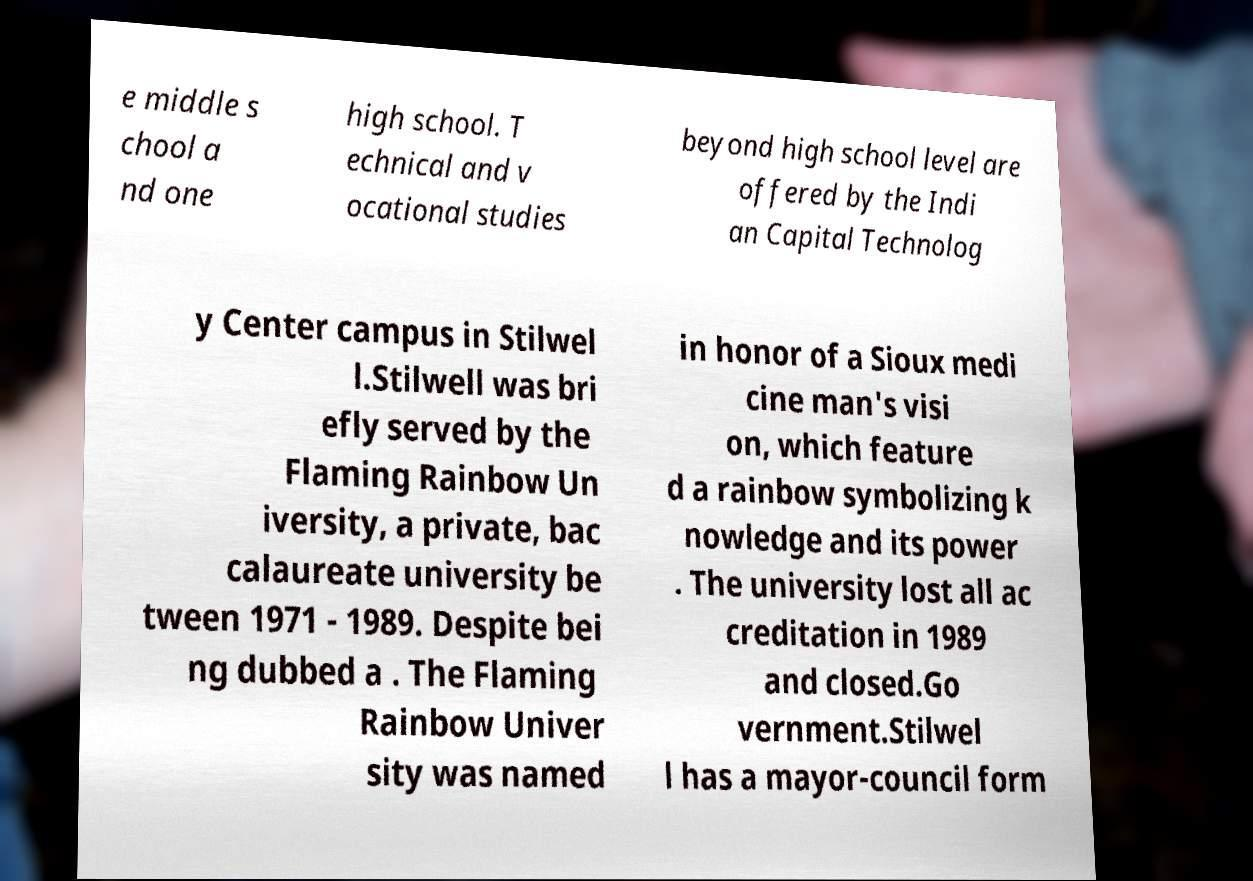Could you assist in decoding the text presented in this image and type it out clearly? e middle s chool a nd one high school. T echnical and v ocational studies beyond high school level are offered by the Indi an Capital Technolog y Center campus in Stilwel l.Stilwell was bri efly served by the Flaming Rainbow Un iversity, a private, bac calaureate university be tween 1971 - 1989. Despite bei ng dubbed a . The Flaming Rainbow Univer sity was named in honor of a Sioux medi cine man's visi on, which feature d a rainbow symbolizing k nowledge and its power . The university lost all ac creditation in 1989 and closed.Go vernment.Stilwel l has a mayor-council form 